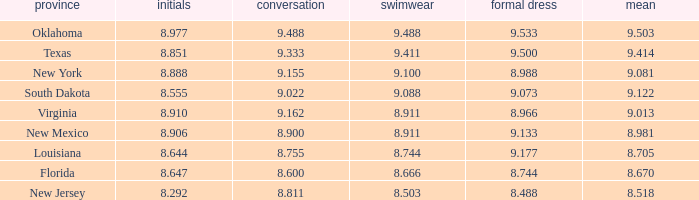What is the total number of average where evening gown is 8.988 1.0. 